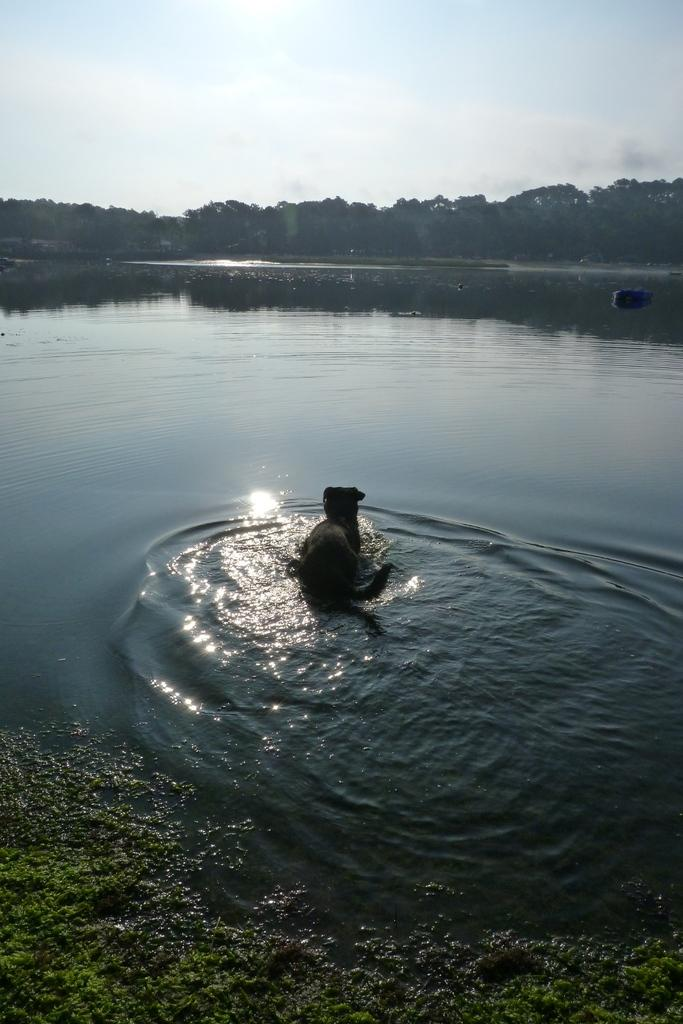What is the animal doing in the water? The animal is in the water, but the specific action cannot be determined from the facts provided. What type of vegetation can be seen in the image? There is grass visible in the image, and there are also trees present. What is the primary element visible in the image? Water is the primary element visible in the image, as the animal is in the water. What is visible in the background of the image? Trees and the sky are visible in the background of the image. What type of knee pain is the animal experiencing in the image? There is no indication of knee pain or any health issues related to the animal in the image. 